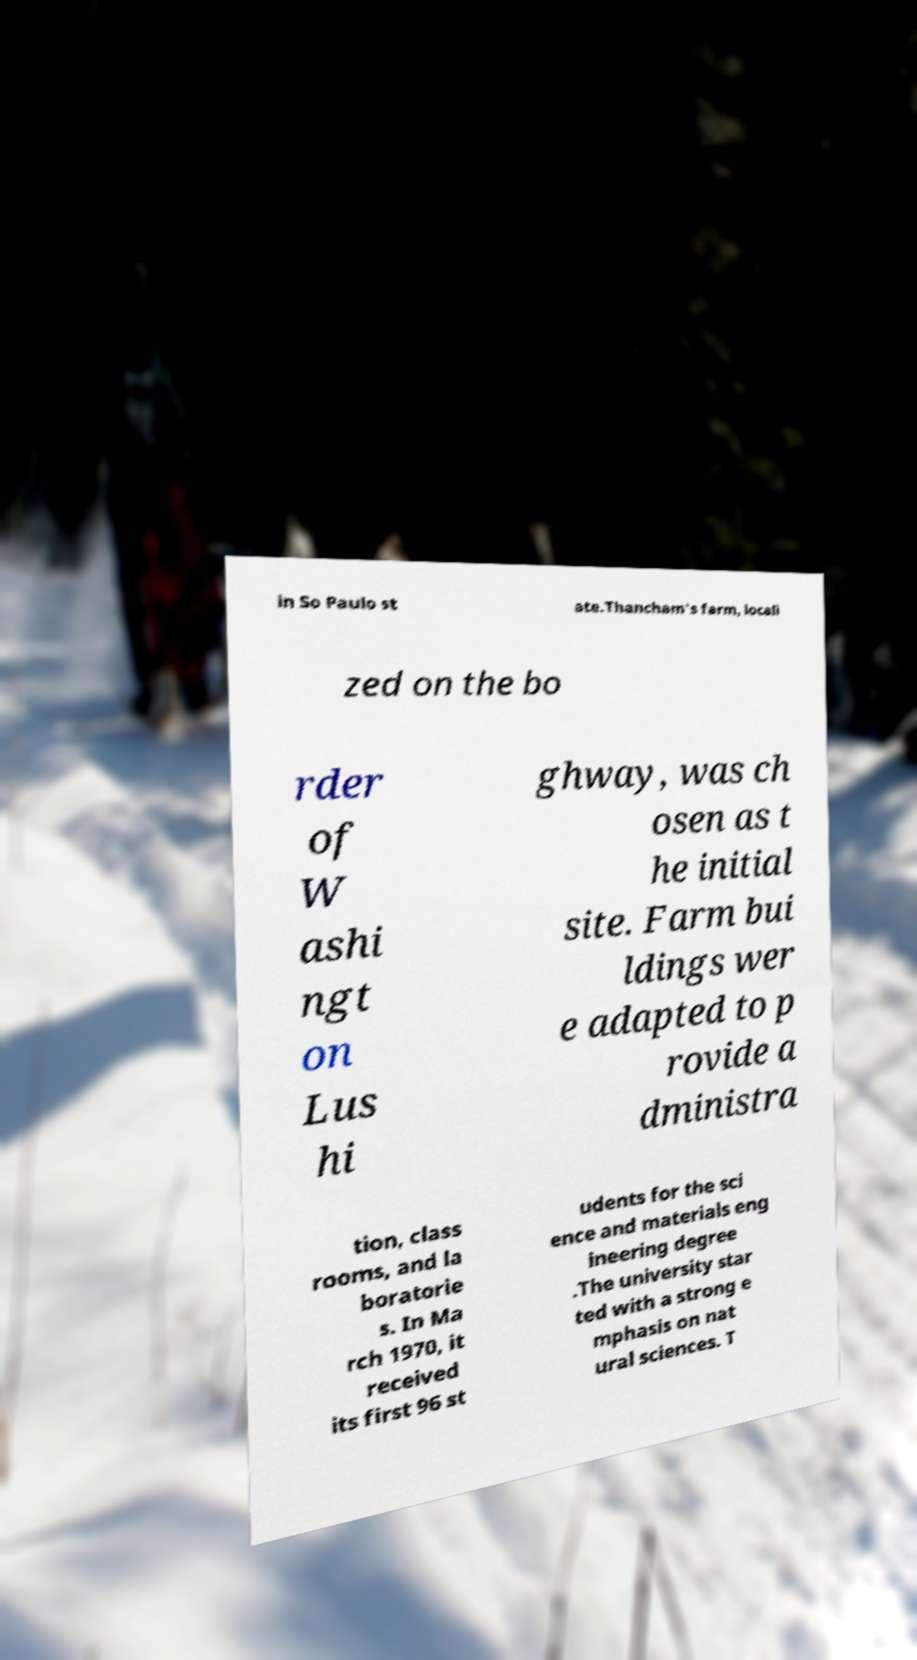Could you extract and type out the text from this image? in So Paulo st ate.Thancham's farm, locali zed on the bo rder of W ashi ngt on Lus hi ghway, was ch osen as t he initial site. Farm bui ldings wer e adapted to p rovide a dministra tion, class rooms, and la boratorie s. In Ma rch 1970, it received its first 96 st udents for the sci ence and materials eng ineering degree .The university star ted with a strong e mphasis on nat ural sciences. T 